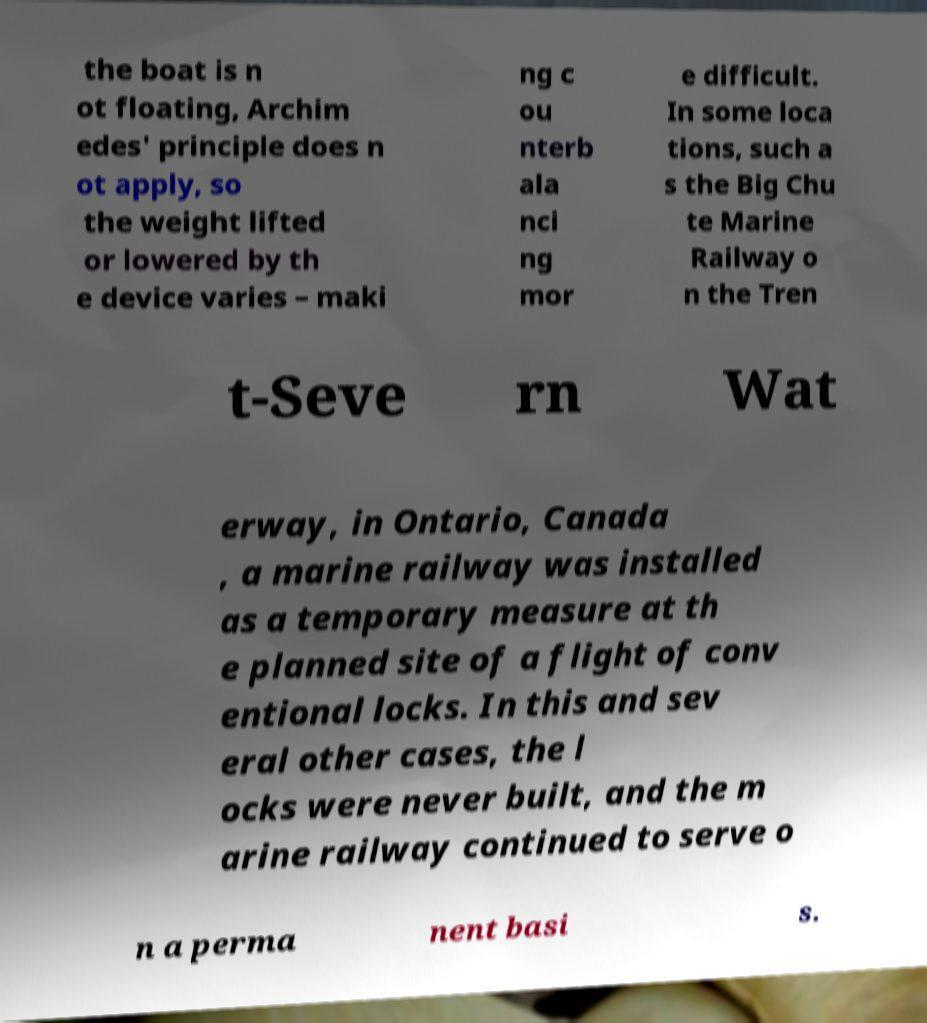I need the written content from this picture converted into text. Can you do that? the boat is n ot floating, Archim edes' principle does n ot apply, so the weight lifted or lowered by th e device varies – maki ng c ou nterb ala nci ng mor e difficult. In some loca tions, such a s the Big Chu te Marine Railway o n the Tren t-Seve rn Wat erway, in Ontario, Canada , a marine railway was installed as a temporary measure at th e planned site of a flight of conv entional locks. In this and sev eral other cases, the l ocks were never built, and the m arine railway continued to serve o n a perma nent basi s. 